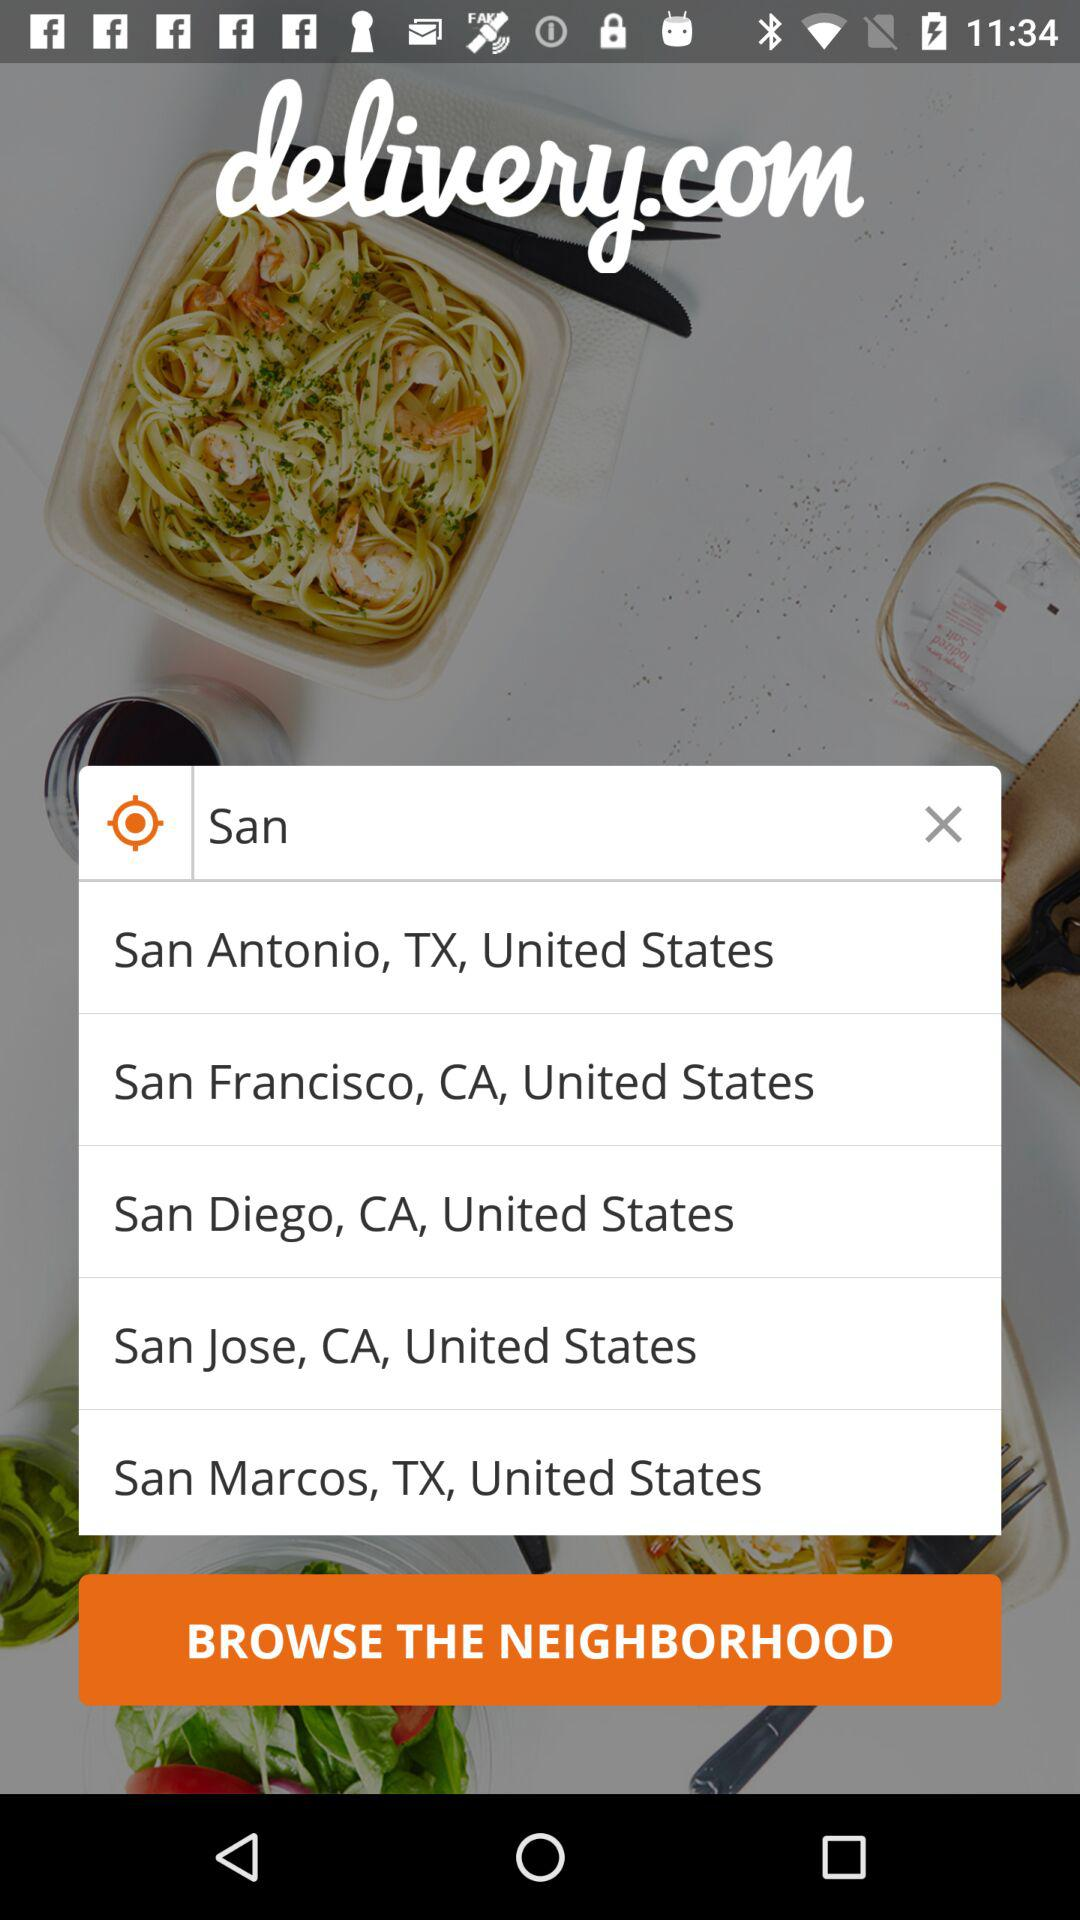What is the name of the application? The application name is "delivery.com". 